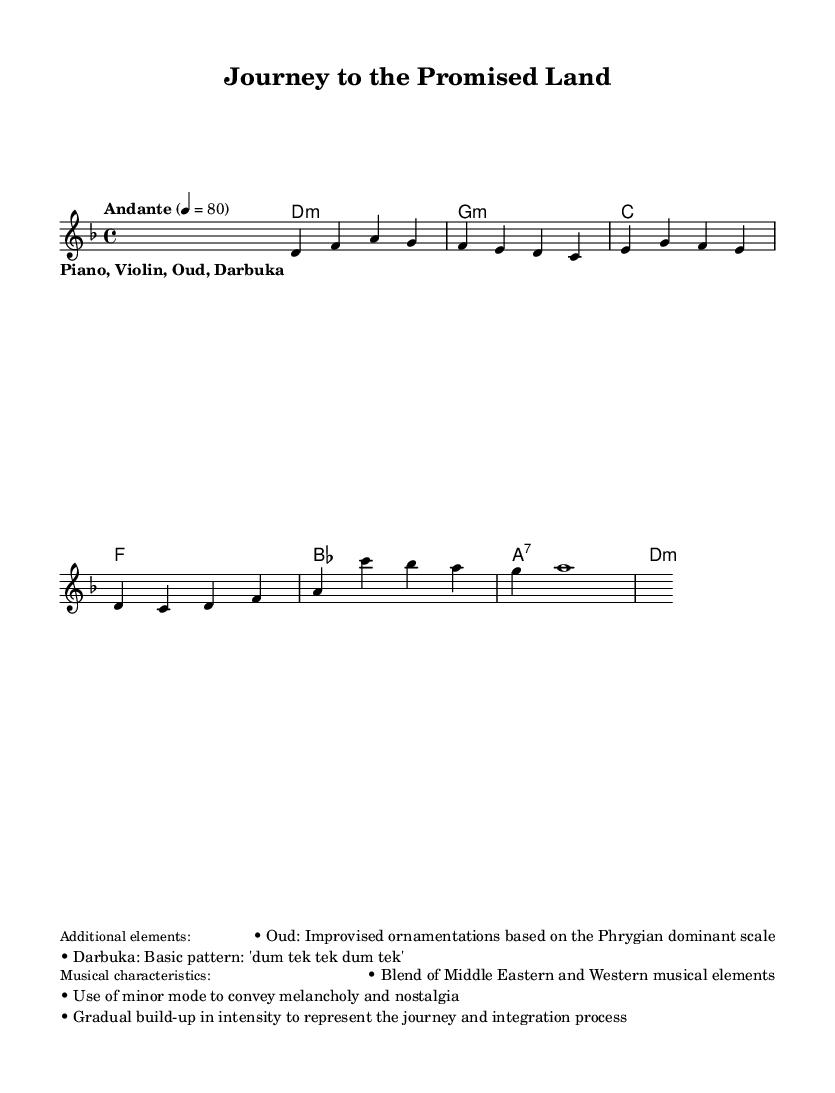What is the key signature of this music? The key signature is D minor, as indicated by the presence of one flat (B flat) in the key signature notation.
Answer: D minor What is the time signature of the piece? The time signature is 4/4, which is shown at the beginning of the sheet music, indicating there are four beats in each measure and a quarter note receives one beat.
Answer: 4/4 What is the tempo marking of the music? The tempo marking is "Andante," which is a common term indicating a moderately slow tempo; it is also accompanied by a metronome marking of 80 beats per minute.
Answer: Andante How many measures are in the melody? The melody consists of four measures, as indicated by the notation. Each phrase separated by vertical bar lines counts as a measure.
Answer: 4 What types of instruments are specified in the lyrics? The specified instruments are Piano, Violin, Oud, and Darbuka, which are listed in the lyrics section under the stanza line.
Answer: Piano, Violin, Oud, Darbuka What musical scale is predominantly used for the Oud ornamentations? The Oud ornamentations are based on the Phrygian dominant scale, which is a mode of the harmonic minor scale commonly used in Middle Eastern music.
Answer: Phrygian dominant What emotions does the use of minor mode convey in this piece? The use of the minor mode conveys melancholy and nostalgia, as it often evokes feelings of sadness and reflection in music.
Answer: Melancholy and nostalgia 